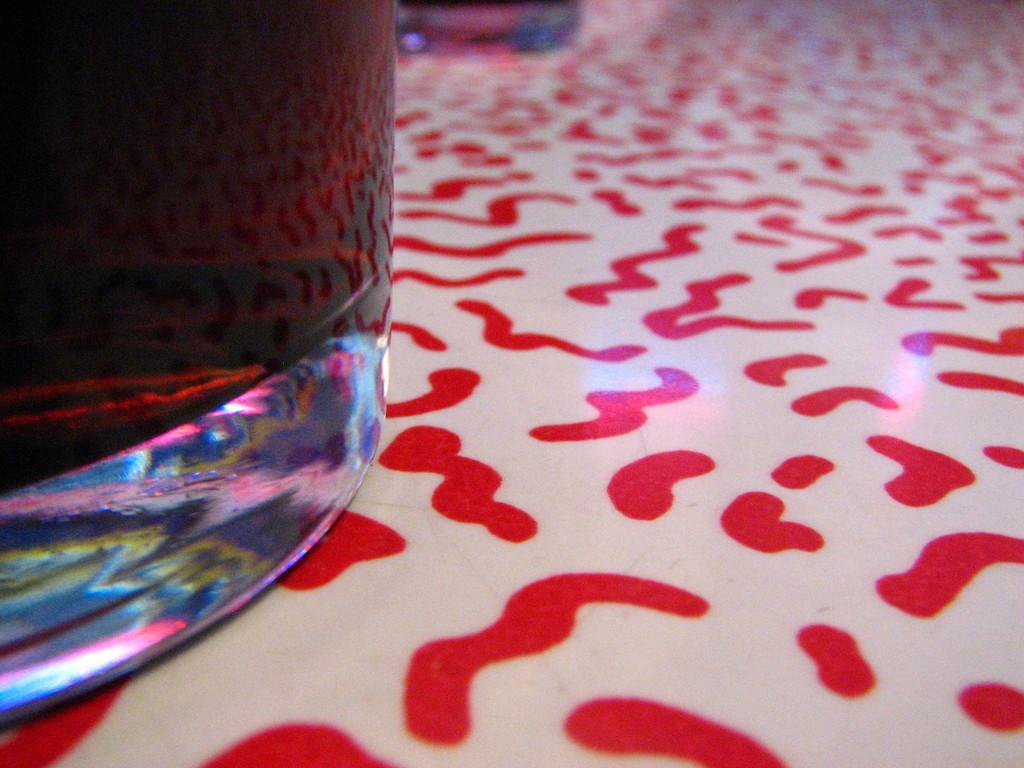What object is located on the left side of the image? There is a glass on the left side of the image. Can you describe the design at the bottom of the image? There is a printed design at the bottom of the image. Is there a person in the image who is attending school? There is no person present in the image, and therefore no indication of anyone attending school. 